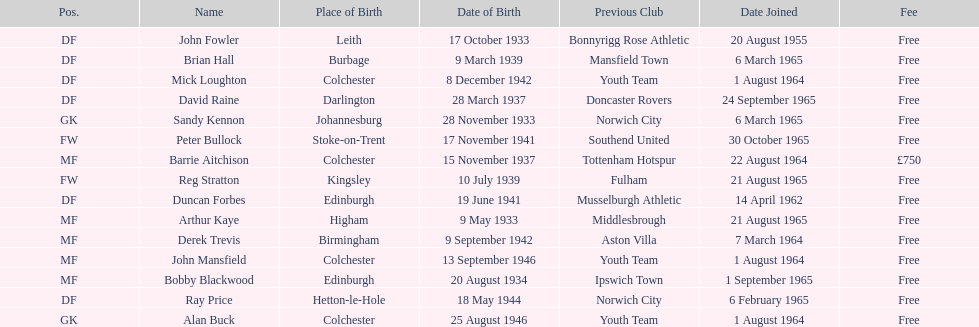Name the player whose fee was not free. Barrie Aitchison. 